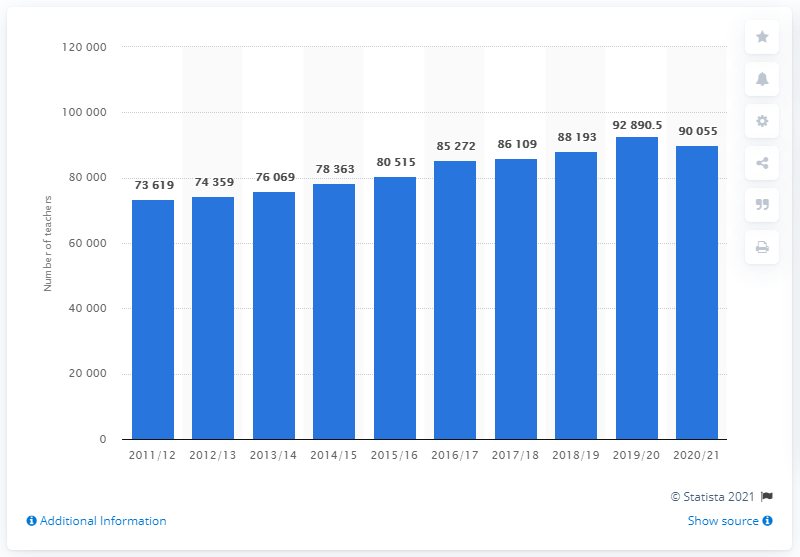Point out several critical features in this image. In the school year 2011/12, there was an increase in the number of teachers in primary schools in Sweden. The average of the last three years is approximately 90,379.5. There are 10 blue bars in the chart. 